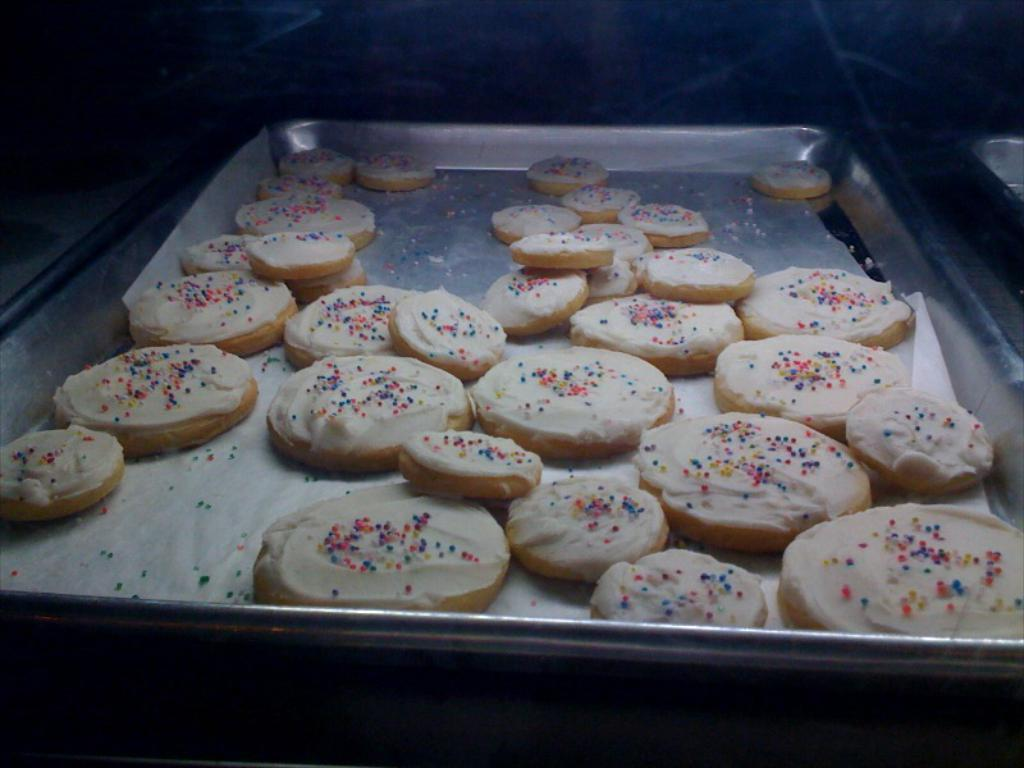What is the main object in the image? There is a steel plate in the image. What is placed on the steel plate? There are cream-colored cookies on the steel plate. Can you describe the background of the image? The image has a slightly dark background. What type of plant can be seen growing on the canvas in the image? There is no canvas or plant present in the image; it features a steel plate with cookies. 